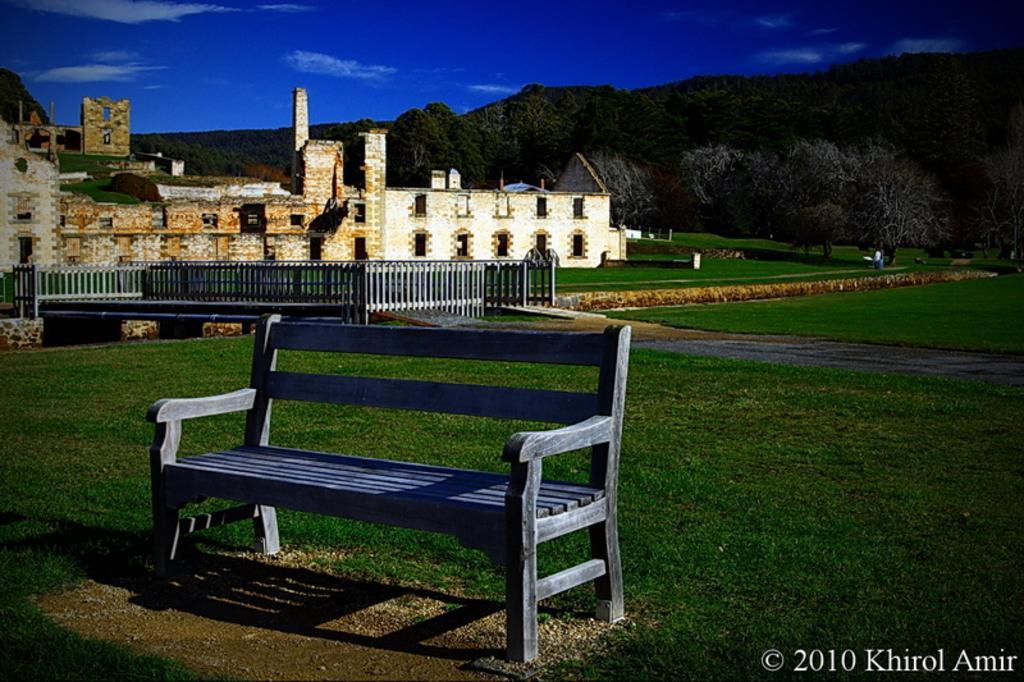How would you summarize this image in a sentence or two? This picture might be taken from outside of the city. In this image, in the middle, we can see a bench. On the left side, we can see a building. In the background, we can see some trees, rocks. At the top, we can see a sky, at the bottom, we can see a grass. 